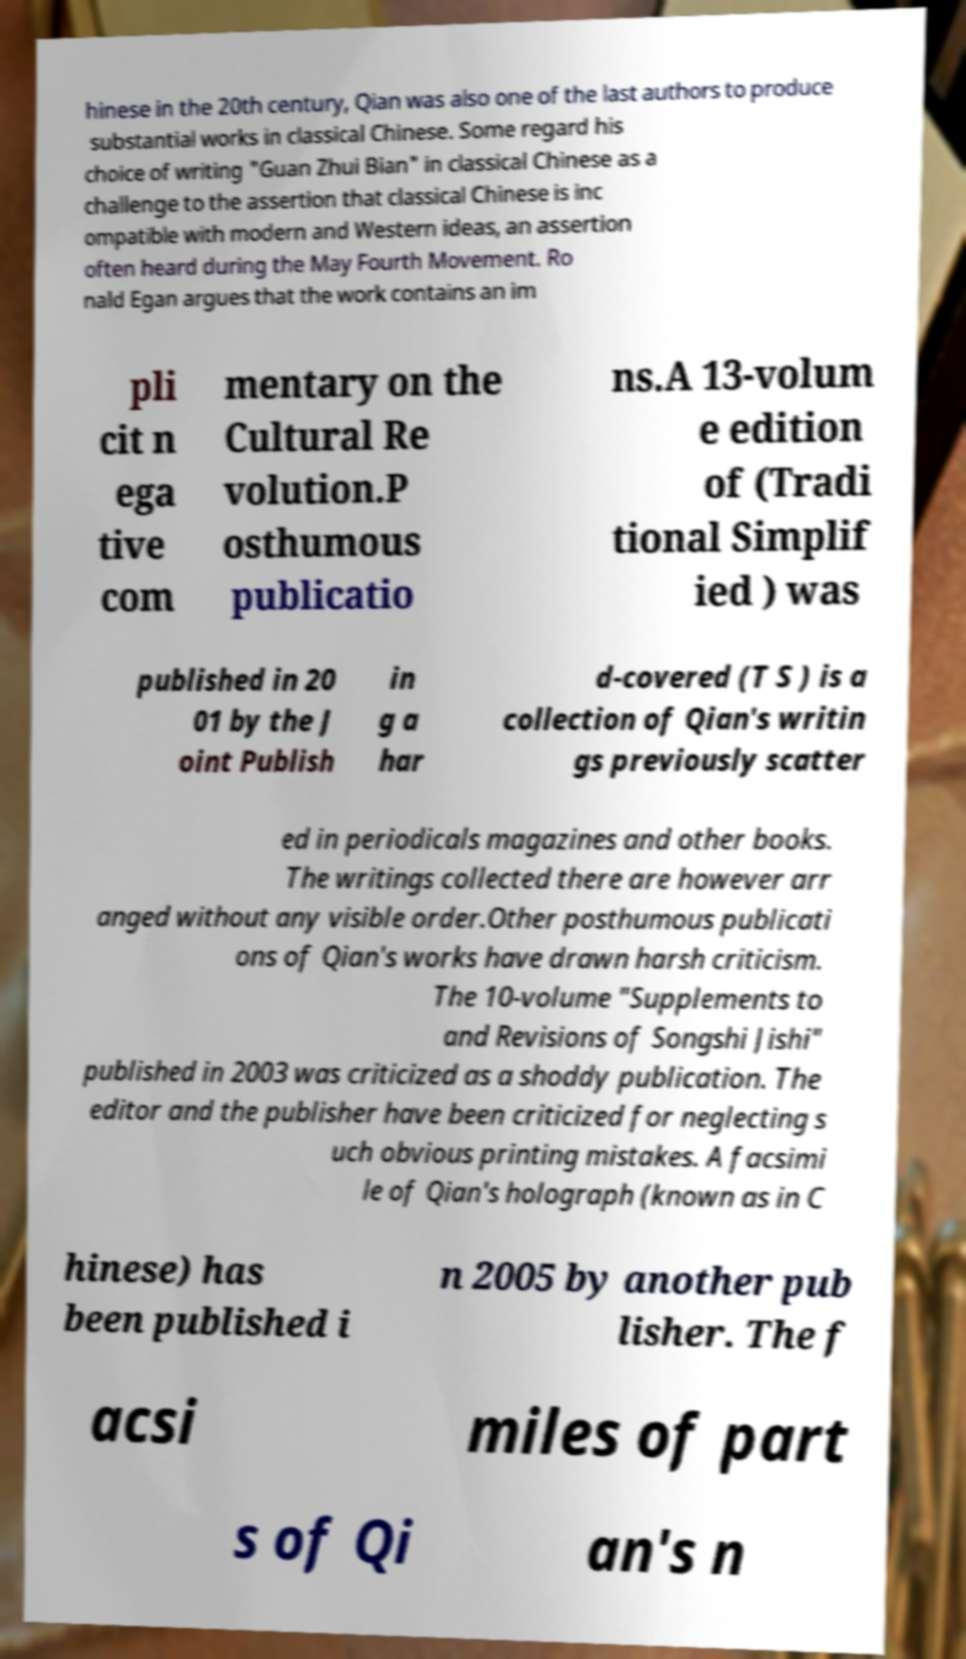Please identify and transcribe the text found in this image. hinese in the 20th century, Qian was also one of the last authors to produce substantial works in classical Chinese. Some regard his choice of writing "Guan Zhui Bian" in classical Chinese as a challenge to the assertion that classical Chinese is inc ompatible with modern and Western ideas, an assertion often heard during the May Fourth Movement. Ro nald Egan argues that the work contains an im pli cit n ega tive com mentary on the Cultural Re volution.P osthumous publicatio ns.A 13-volum e edition of (Tradi tional Simplif ied ) was published in 20 01 by the J oint Publish in g a har d-covered (T S ) is a collection of Qian's writin gs previously scatter ed in periodicals magazines and other books. The writings collected there are however arr anged without any visible order.Other posthumous publicati ons of Qian's works have drawn harsh criticism. The 10-volume "Supplements to and Revisions of Songshi Jishi" published in 2003 was criticized as a shoddy publication. The editor and the publisher have been criticized for neglecting s uch obvious printing mistakes. A facsimi le of Qian's holograph (known as in C hinese) has been published i n 2005 by another pub lisher. The f acsi miles of part s of Qi an's n 